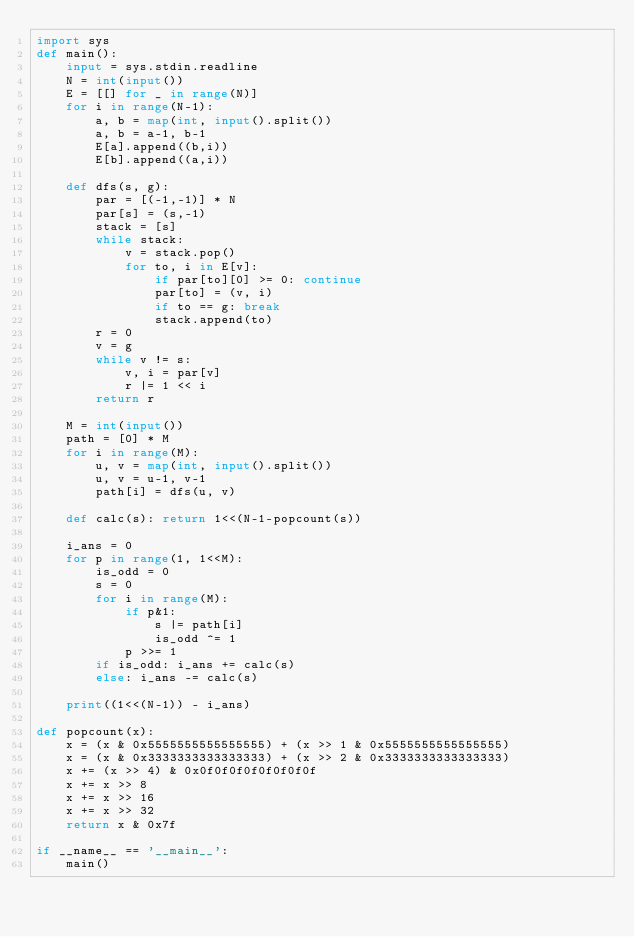Convert code to text. <code><loc_0><loc_0><loc_500><loc_500><_Python_>import sys
def main():
    input = sys.stdin.readline
    N = int(input())
    E = [[] for _ in range(N)]
    for i in range(N-1):
        a, b = map(int, input().split())
        a, b = a-1, b-1
        E[a].append((b,i))
        E[b].append((a,i))
    
    def dfs(s, g):
        par = [(-1,-1)] * N
        par[s] = (s,-1)
        stack = [s]
        while stack:
            v = stack.pop()
            for to, i in E[v]:
                if par[to][0] >= 0: continue
                par[to] = (v, i)
                if to == g: break
                stack.append(to)
        r = 0
        v = g
        while v != s:
            v, i = par[v]
            r |= 1 << i
        return r
    
    M = int(input())
    path = [0] * M
    for i in range(M):
        u, v = map(int, input().split())
        u, v = u-1, v-1
        path[i] = dfs(u, v)

    def calc(s): return 1<<(N-1-popcount(s))

    i_ans = 0
    for p in range(1, 1<<M):
        is_odd = 0
        s = 0
        for i in range(M):
            if p&1:
                s |= path[i]
                is_odd ^= 1
            p >>= 1
        if is_odd: i_ans += calc(s)
        else: i_ans -= calc(s)

    print((1<<(N-1)) - i_ans)

def popcount(x):
    x = (x & 0x5555555555555555) + (x >> 1 & 0x5555555555555555)
    x = (x & 0x3333333333333333) + (x >> 2 & 0x3333333333333333)
    x += (x >> 4) & 0x0f0f0f0f0f0f0f0f
    x += x >> 8
    x += x >> 16
    x += x >> 32
    return x & 0x7f

if __name__ == '__main__':
    main()</code> 